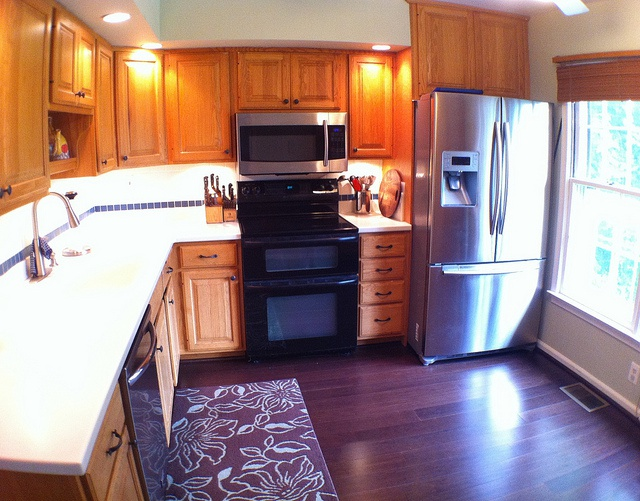Describe the objects in this image and their specific colors. I can see refrigerator in red, white, purple, and blue tones, oven in red, black, navy, darkblue, and maroon tones, microwave in red, black, brown, gray, and salmon tones, sink in red, white, lightpink, and pink tones, and bottle in red, maroon, salmon, and black tones in this image. 